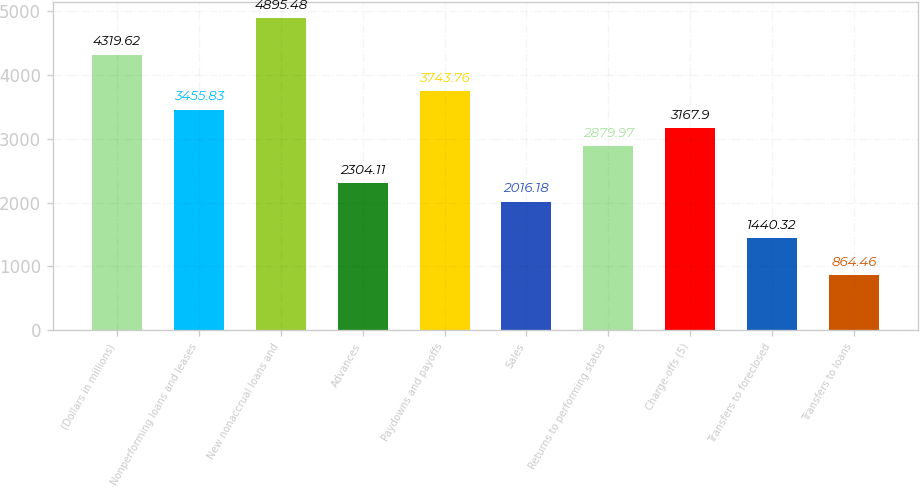Convert chart to OTSL. <chart><loc_0><loc_0><loc_500><loc_500><bar_chart><fcel>(Dollars in millions)<fcel>Nonperforming loans and leases<fcel>New nonaccrual loans and<fcel>Advances<fcel>Paydowns and payoffs<fcel>Sales<fcel>Returns to performing status<fcel>Charge-offs (5)<fcel>Transfers to foreclosed<fcel>Transfers to loans<nl><fcel>4319.62<fcel>3455.83<fcel>4895.48<fcel>2304.11<fcel>3743.76<fcel>2016.18<fcel>2879.97<fcel>3167.9<fcel>1440.32<fcel>864.46<nl></chart> 